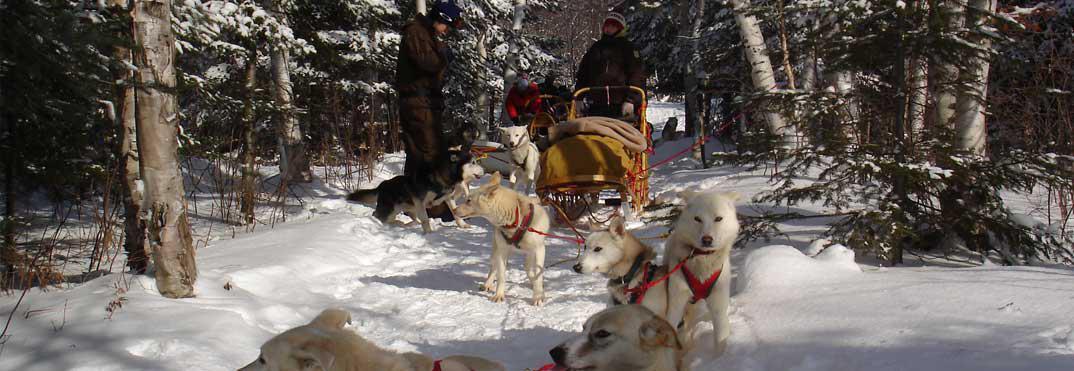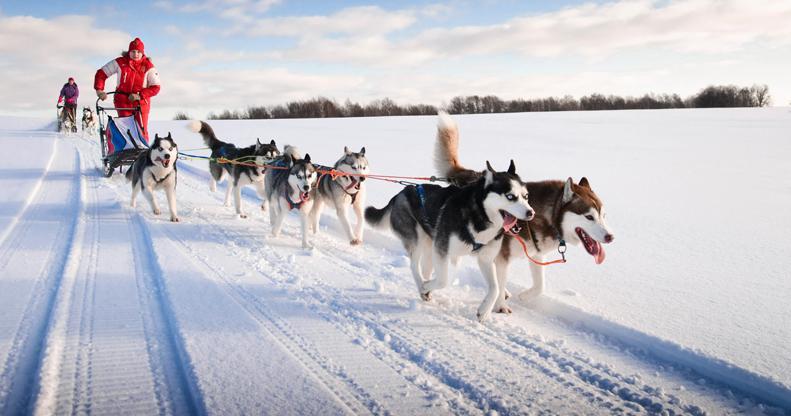The first image is the image on the left, the second image is the image on the right. Evaluate the accuracy of this statement regarding the images: "One image features a sled dog team that is heading forward at an angle across a flattened snow path to the right.". Is it true? Answer yes or no. Yes. 